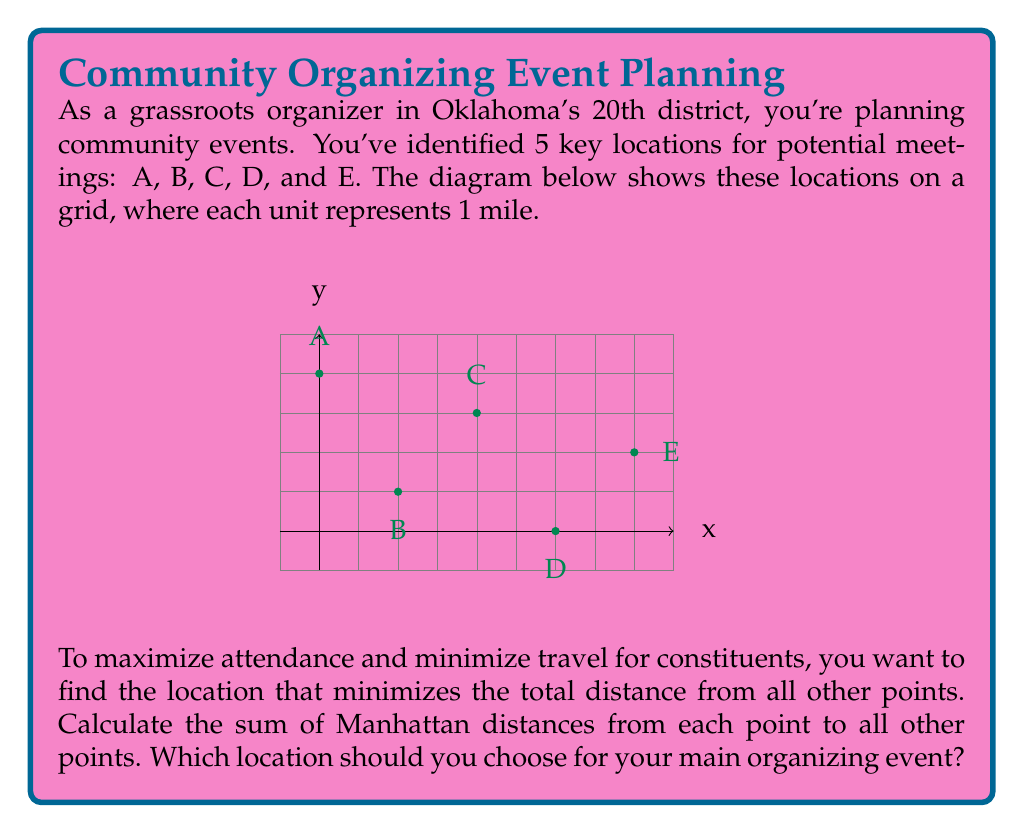Help me with this question. Let's approach this step-by-step:

1) First, we need to calculate the Manhattan distance between each pair of points. The Manhattan distance is the sum of the absolute differences of the coordinates.

2) For each point, we'll calculate its distance to all other points:

   Point A (0,4):
   To B: |0-2| + |4-1| = 5
   To C: |0-4| + |4-3| = 5
   To D: |0-6| + |4-0| = 10
   To E: |0-8| + |4-2| = 10
   Total: 30

   Point B (2,1):
   To A: |2-0| + |1-4| = 5
   To C: |2-4| + |1-3| = 4
   To D: |2-6| + |1-0| = 5
   To E: |2-8| + |1-2| = 7
   Total: 21

   Point C (4,3):
   To A: |4-0| + |3-4| = 5
   To B: |4-2| + |3-1| = 4
   To D: |4-6| + |3-0| = 5
   To E: |4-8| + |3-2| = 5
   Total: 19

   Point D (6,0):
   To A: |6-0| + |0-4| = 10
   To B: |6-2| + |0-1| = 5
   To C: |6-4| + |0-3| = 5
   To E: |6-8| + |0-2| = 4
   Total: 24

   Point E (8,2):
   To A: |8-0| + |2-4| = 10
   To B: |8-2| + |2-1| = 7
   To C: |8-4| + |2-3| = 5
   To D: |8-6| + |2-0| = 4
   Total: 26

3) The point with the minimum total distance is Point C with a total distance of 19.
Answer: Point C (4,3) 